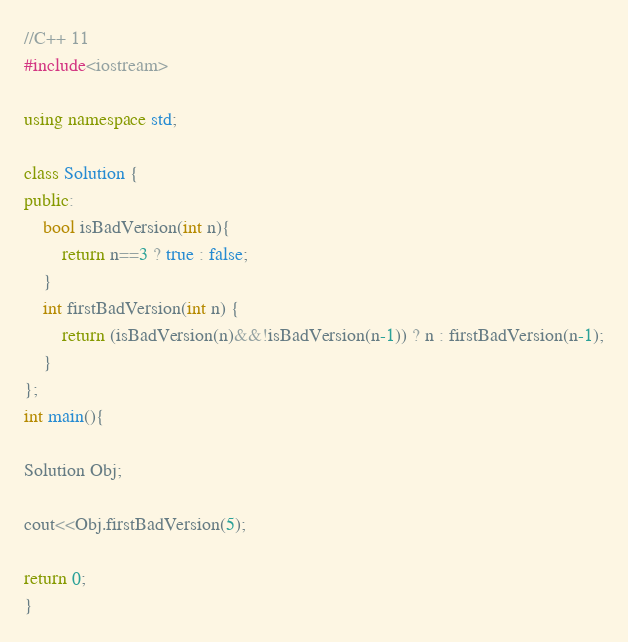Convert code to text. <code><loc_0><loc_0><loc_500><loc_500><_C++_>//C++ 11
#include<iostream>

using namespace std;

class Solution {
public:
	bool isBadVersion(int n){
		return n==3 ? true : false;
	}
 	int firstBadVersion(int n) {
        return (isBadVersion(n)&&!isBadVersion(n-1)) ? n : firstBadVersion(n-1);
    }
};
int main(){

Solution Obj;

cout<<Obj.firstBadVersion(5);

return 0;
}

</code> 